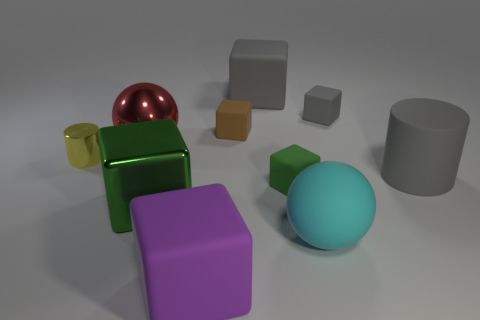How many other objects are there of the same material as the cyan sphere?
Provide a succinct answer. 6. What is the size of the brown matte object that is the same shape as the big purple matte object?
Provide a succinct answer. Small. What number of matte objects are both behind the yellow cylinder and on the right side of the green matte object?
Offer a terse response. 1. Are there an equal number of purple matte things that are on the right side of the large gray matte cylinder and small brown matte blocks that are on the right side of the green metallic thing?
Provide a short and direct response. No. Is the size of the ball that is behind the green rubber cube the same as the green block on the right side of the purple object?
Offer a terse response. No. There is a block that is both behind the green metal block and in front of the tiny brown rubber object; what material is it made of?
Give a very brief answer. Rubber. Is the number of rubber objects less than the number of objects?
Offer a terse response. Yes. There is a green thing in front of the tiny block in front of the metallic cylinder; what is its size?
Provide a succinct answer. Large. There is a tiny yellow shiny thing in front of the ball behind the block left of the purple matte cube; what shape is it?
Your answer should be compact. Cylinder. There is a big ball that is the same material as the tiny brown block; what is its color?
Keep it short and to the point. Cyan. 